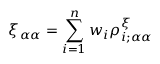<formula> <loc_0><loc_0><loc_500><loc_500>\xi _ { \alpha \alpha } = \sum _ { i = 1 } ^ { n } w _ { i } \rho _ { i ; \alpha \alpha } ^ { \xi }</formula> 